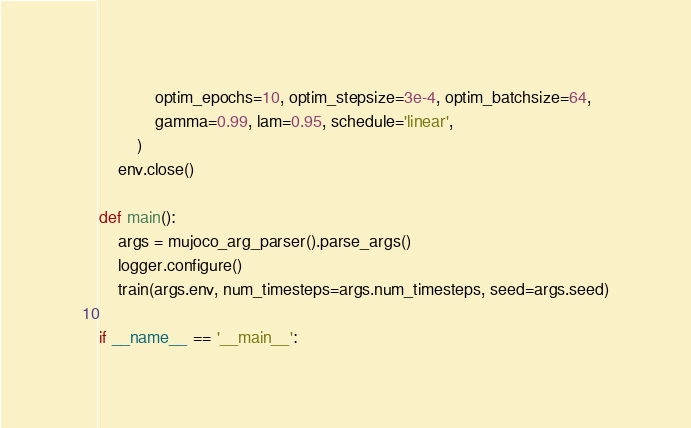Convert code to text. <code><loc_0><loc_0><loc_500><loc_500><_Python_>            optim_epochs=10, optim_stepsize=3e-4, optim_batchsize=64,
            gamma=0.99, lam=0.95, schedule='linear',
        )
    env.close()

def main():
    args = mujoco_arg_parser().parse_args()
    logger.configure()
    train(args.env, num_timesteps=args.num_timesteps, seed=args.seed)

if __name__ == '__main__':</code> 